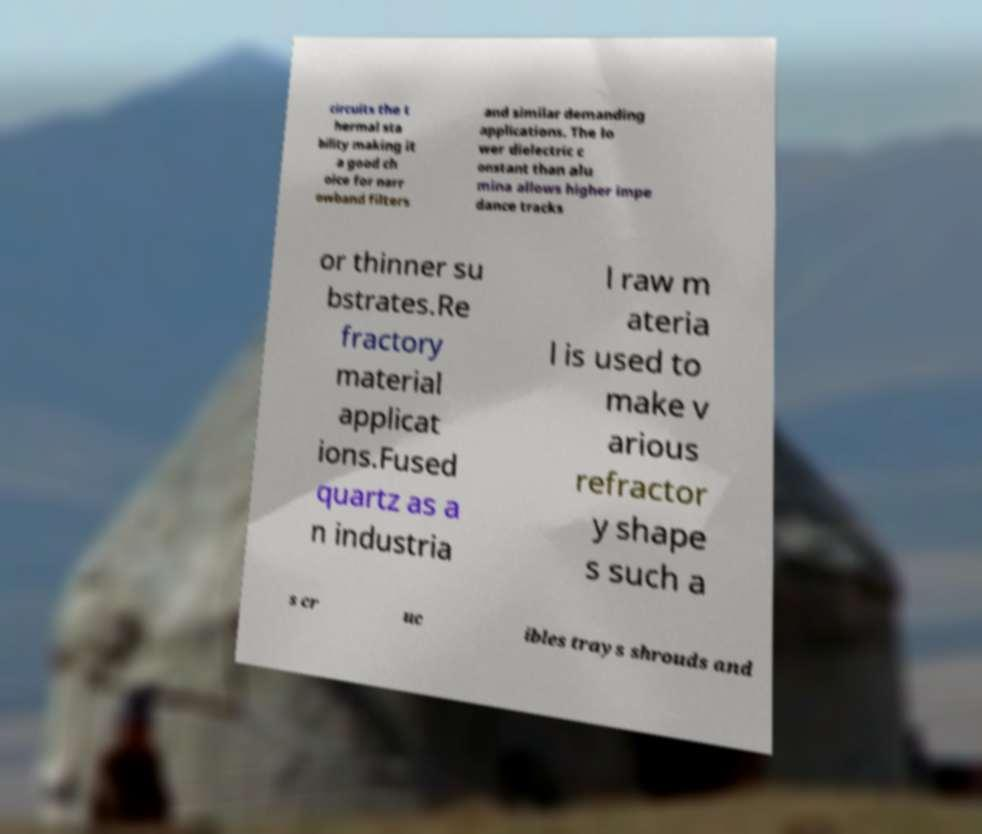Could you assist in decoding the text presented in this image and type it out clearly? circuits the t hermal sta bility making it a good ch oice for narr owband filters and similar demanding applications. The lo wer dielectric c onstant than alu mina allows higher impe dance tracks or thinner su bstrates.Re fractory material applicat ions.Fused quartz as a n industria l raw m ateria l is used to make v arious refractor y shape s such a s cr uc ibles trays shrouds and 